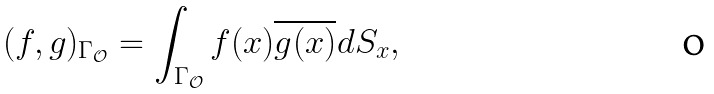<formula> <loc_0><loc_0><loc_500><loc_500>( f , g ) _ { \Gamma _ { \mathcal { O } } } = \int _ { \Gamma _ { \mathcal { O } } } f ( x ) \overline { g ( x ) } d S _ { x } ,</formula> 